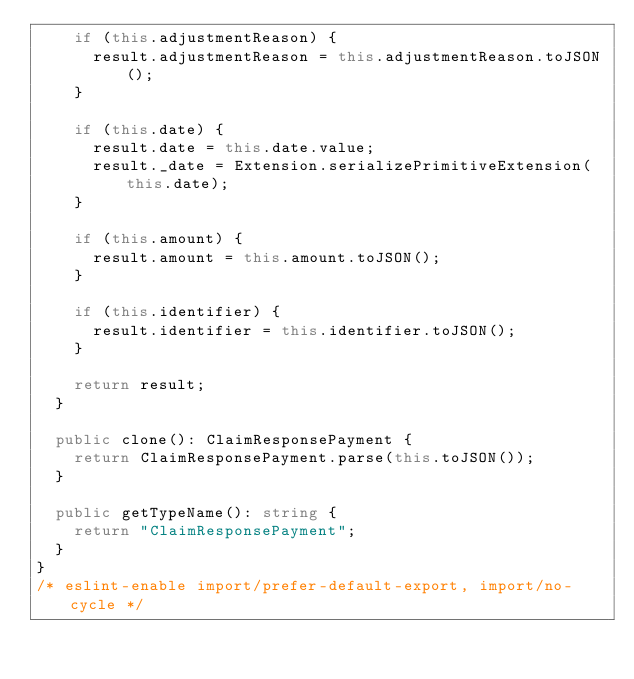Convert code to text. <code><loc_0><loc_0><loc_500><loc_500><_TypeScript_>    if (this.adjustmentReason) {
      result.adjustmentReason = this.adjustmentReason.toJSON();
    }

    if (this.date) {
      result.date = this.date.value;
      result._date = Extension.serializePrimitiveExtension(this.date);
    }

    if (this.amount) {
      result.amount = this.amount.toJSON();
    }

    if (this.identifier) {
      result.identifier = this.identifier.toJSON();
    }

    return result;
  }

  public clone(): ClaimResponsePayment {
    return ClaimResponsePayment.parse(this.toJSON());
  }

  public getTypeName(): string {
    return "ClaimResponsePayment";
  }
}
/* eslint-enable import/prefer-default-export, import/no-cycle */
</code> 